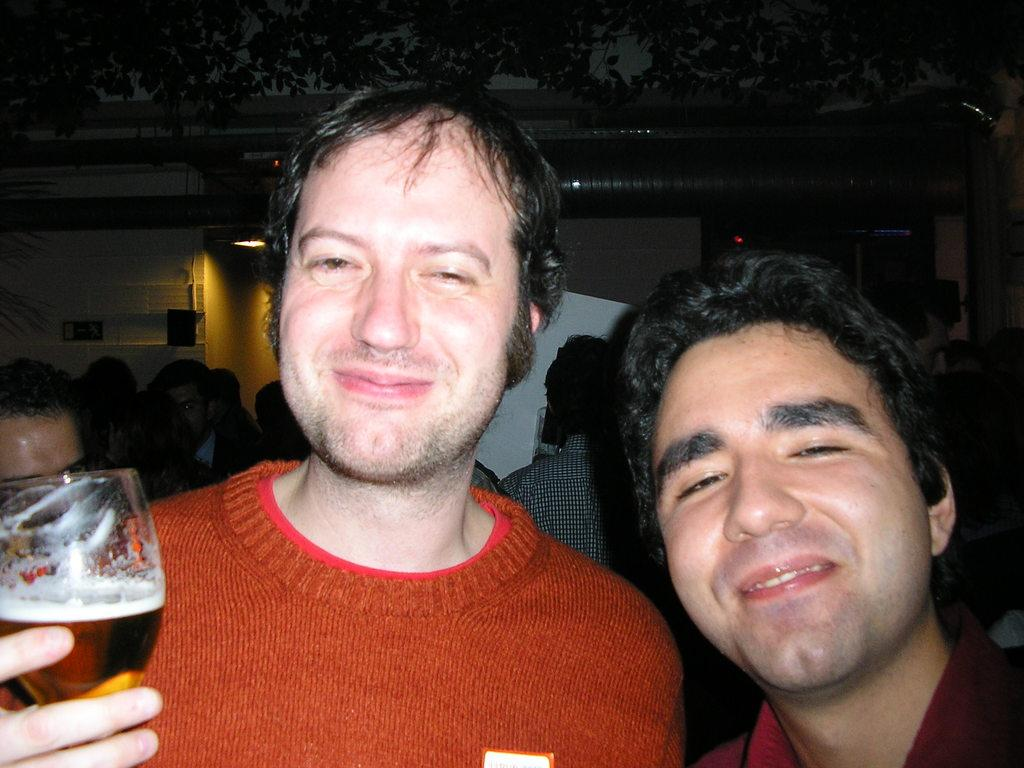How many people are in the image? There are two men in the image. What are the men doing in the image? The men are smiling in the image. What is one of the men holding? One of the men is holding a glass. What can be seen in the background of the image? There are people and a tree in the background of the image. What type of powder is being used by the men in the image? There is no powder present in the image; the men are simply smiling and one is holding a glass. What flag is being waved by the people in the background of the image? There is no flag visible in the image; only people and a tree can be seen in the background. 